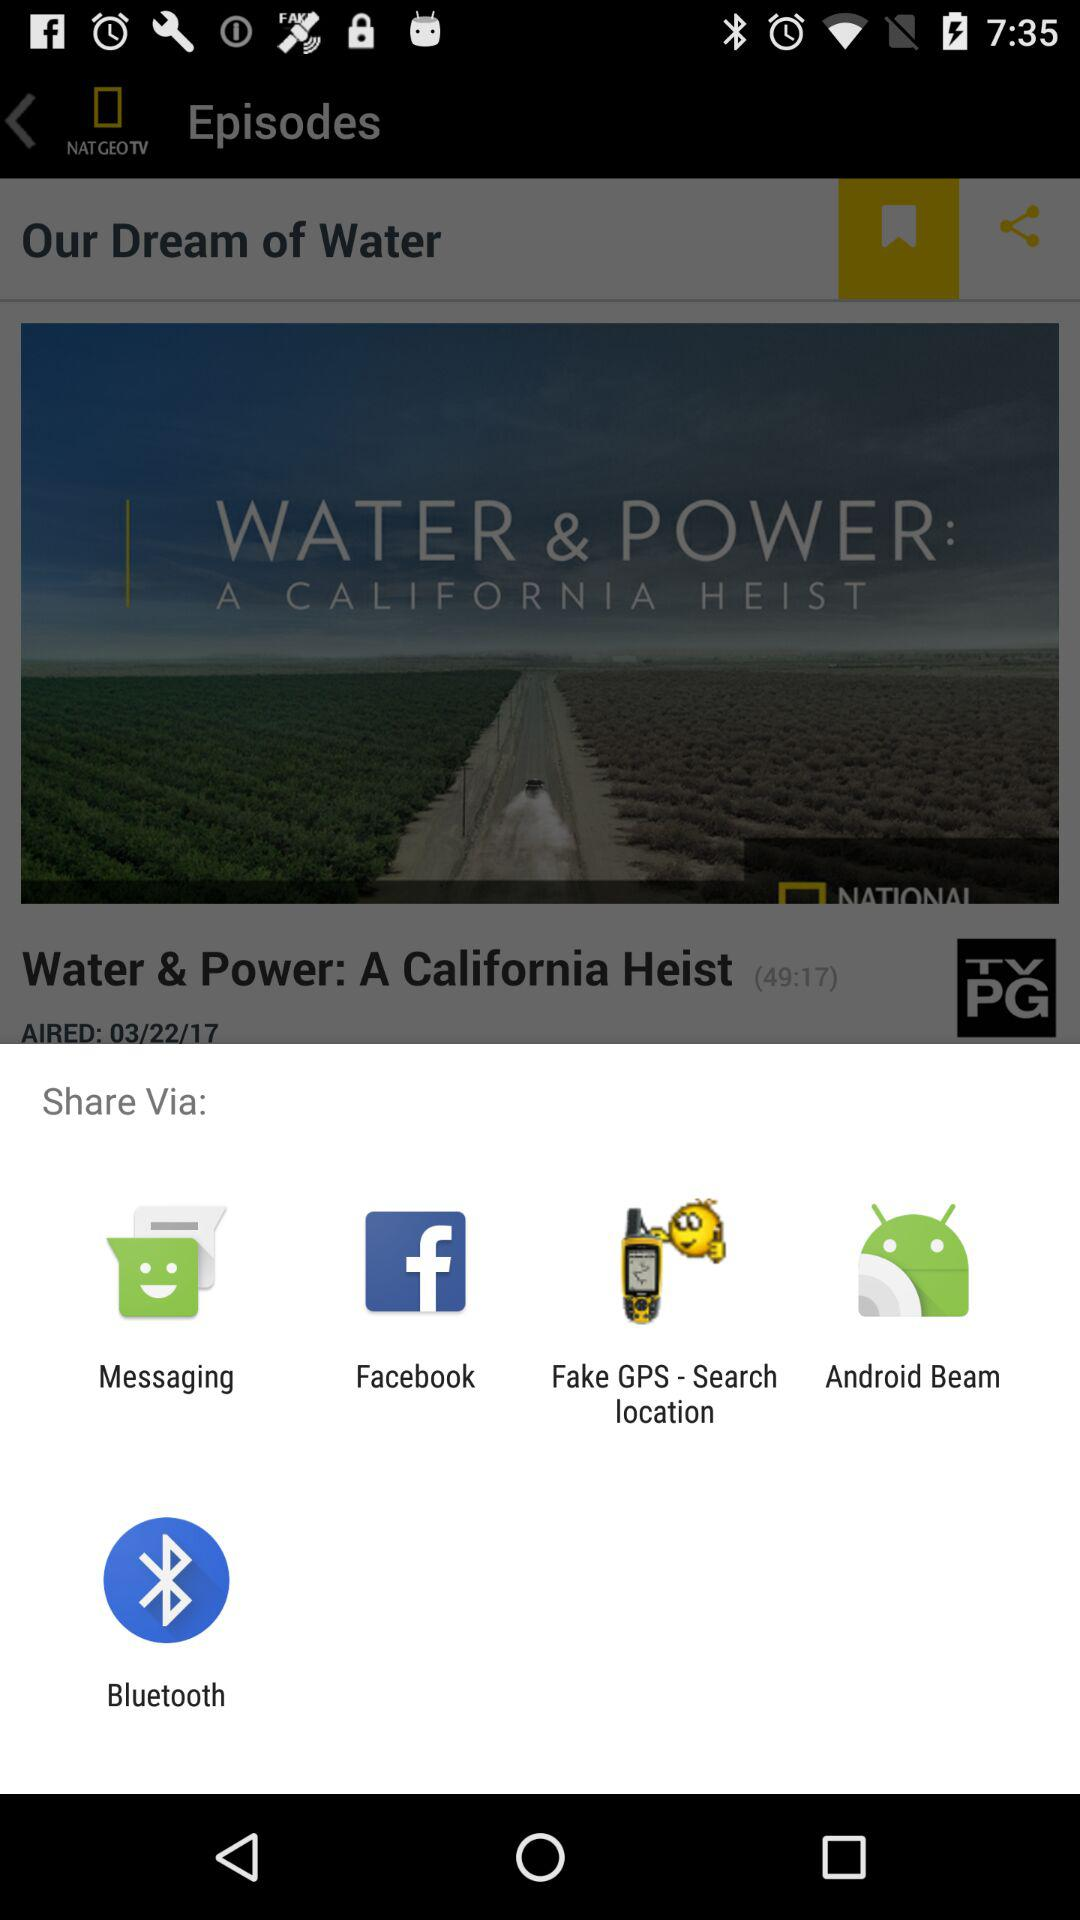How long is the movie? The movie is 49 minutes and 17 seconds long. 